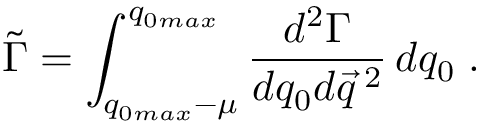Convert formula to latex. <formula><loc_0><loc_0><loc_500><loc_500>\tilde { \Gamma } = \int _ { q _ { 0 \max } - \mu } ^ { q _ { 0 \max } } \frac { d ^ { 2 } \Gamma } { d q _ { 0 } d \vec { q } \, ^ { 2 } } \, d q _ { 0 } \, .</formula> 